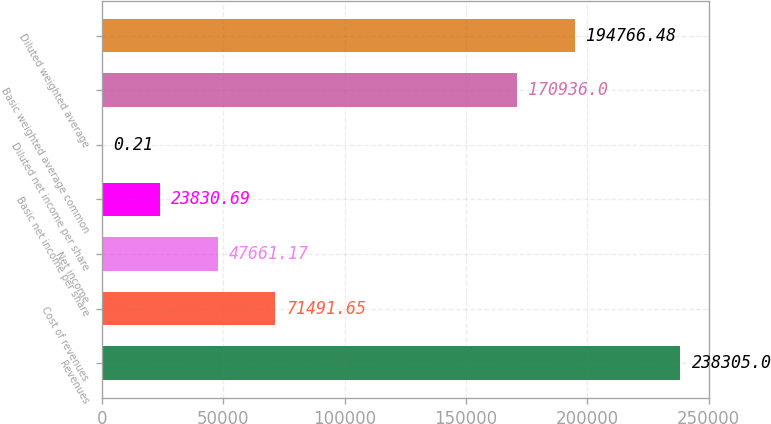Convert chart. <chart><loc_0><loc_0><loc_500><loc_500><bar_chart><fcel>Revenues<fcel>Cost of revenues<fcel>Net income<fcel>Basic net income per share<fcel>Diluted net income per share<fcel>Basic weighted average common<fcel>Diluted weighted average<nl><fcel>238305<fcel>71491.6<fcel>47661.2<fcel>23830.7<fcel>0.21<fcel>170936<fcel>194766<nl></chart> 